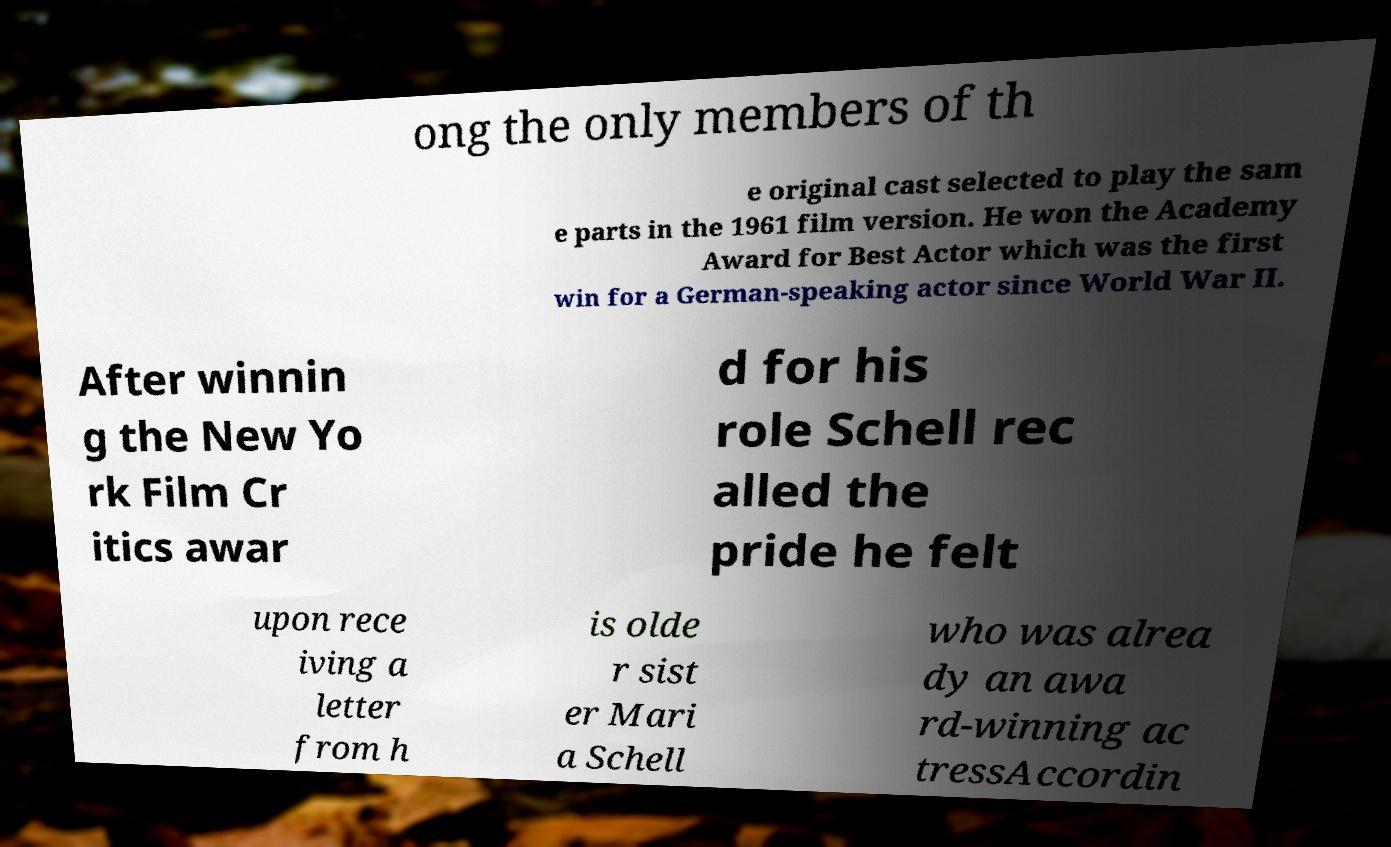For documentation purposes, I need the text within this image transcribed. Could you provide that? ong the only members of th e original cast selected to play the sam e parts in the 1961 film version. He won the Academy Award for Best Actor which was the first win for a German-speaking actor since World War II. After winnin g the New Yo rk Film Cr itics awar d for his role Schell rec alled the pride he felt upon rece iving a letter from h is olde r sist er Mari a Schell who was alrea dy an awa rd-winning ac tressAccordin 